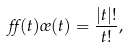Convert formula to latex. <formula><loc_0><loc_0><loc_500><loc_500>\alpha ( t ) \sigma ( t ) = \frac { | t | ! } { t ! } ,</formula> 